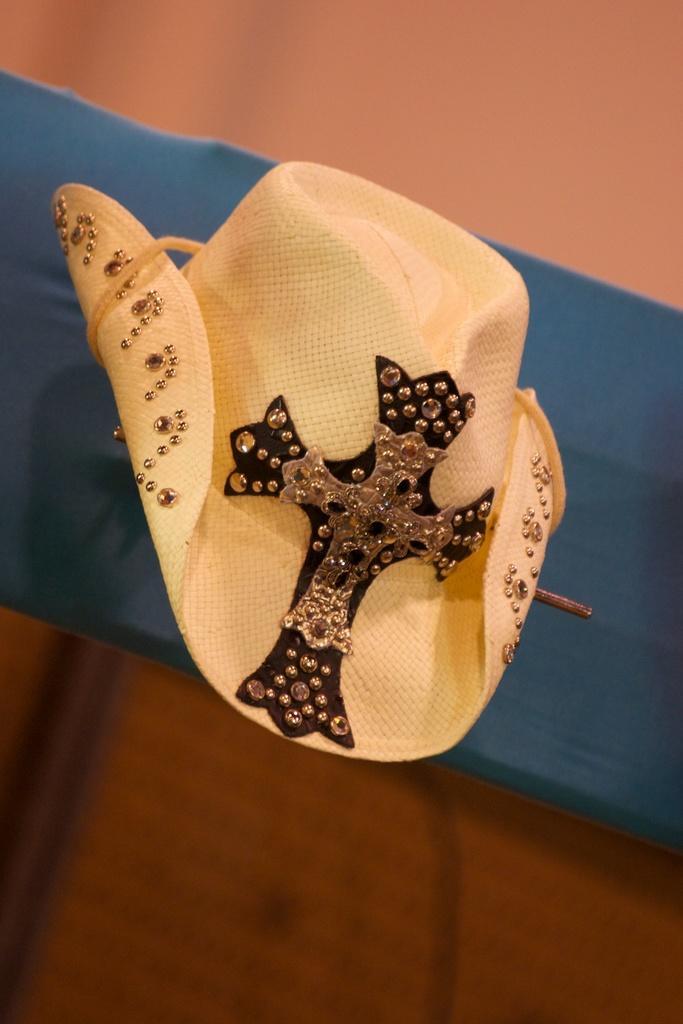Describe this image in one or two sentences. In the center of the image we can see cloth, hat. In the background of the image there is a wall. 